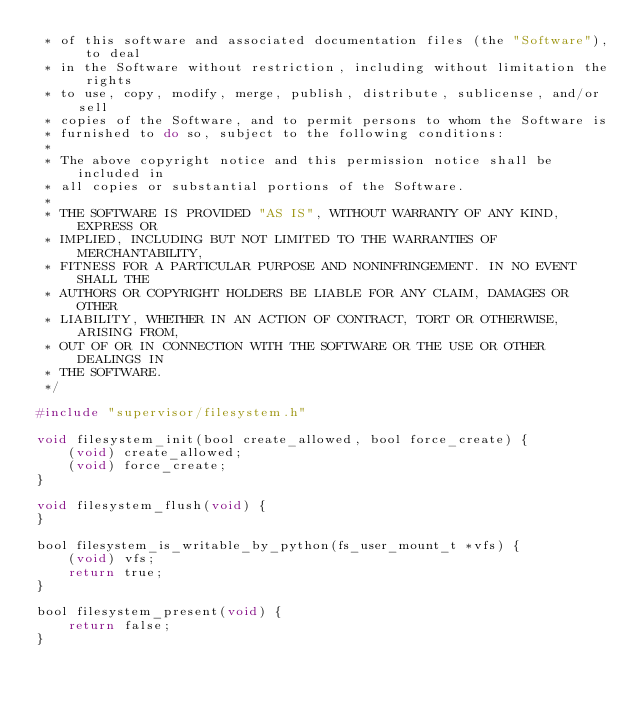Convert code to text. <code><loc_0><loc_0><loc_500><loc_500><_C_> * of this software and associated documentation files (the "Software"), to deal
 * in the Software without restriction, including without limitation the rights
 * to use, copy, modify, merge, publish, distribute, sublicense, and/or sell
 * copies of the Software, and to permit persons to whom the Software is
 * furnished to do so, subject to the following conditions:
 *
 * The above copyright notice and this permission notice shall be included in
 * all copies or substantial portions of the Software.
 *
 * THE SOFTWARE IS PROVIDED "AS IS", WITHOUT WARRANTY OF ANY KIND, EXPRESS OR
 * IMPLIED, INCLUDING BUT NOT LIMITED TO THE WARRANTIES OF MERCHANTABILITY,
 * FITNESS FOR A PARTICULAR PURPOSE AND NONINFRINGEMENT. IN NO EVENT SHALL THE
 * AUTHORS OR COPYRIGHT HOLDERS BE LIABLE FOR ANY CLAIM, DAMAGES OR OTHER
 * LIABILITY, WHETHER IN AN ACTION OF CONTRACT, TORT OR OTHERWISE, ARISING FROM,
 * OUT OF OR IN CONNECTION WITH THE SOFTWARE OR THE USE OR OTHER DEALINGS IN
 * THE SOFTWARE.
 */

#include "supervisor/filesystem.h"

void filesystem_init(bool create_allowed, bool force_create) {
    (void) create_allowed;
    (void) force_create;
}

void filesystem_flush(void) {
}

bool filesystem_is_writable_by_python(fs_user_mount_t *vfs) {
    (void) vfs;
    return true;
}

bool filesystem_present(void) {
    return false;
}
</code> 